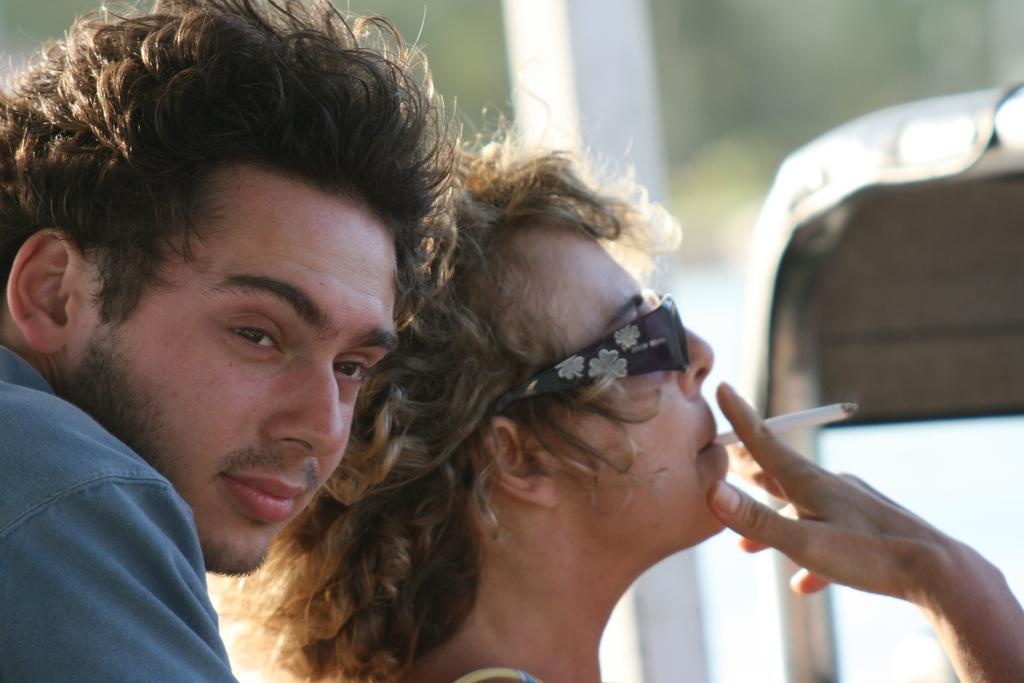How many people are in the image? There are two persons in the image. What is one of the persons doing in the image? One of the persons is smoking a cigar. What type of dog can be seen playing with a bat in the image? There is no dog or bat present in the image; it features two persons, one of whom is smoking a cigar. What kind of coil is being used by the person smoking the cigar? The provided facts do not mention any coil being used by the person smoking the cigar. 